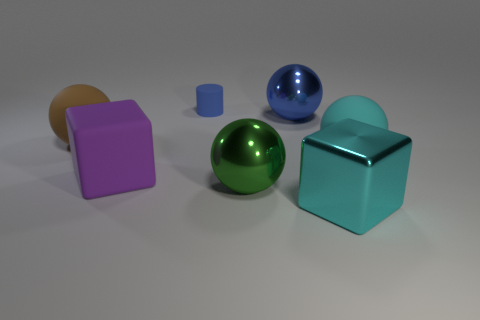What size is the metal sphere that is the same color as the tiny rubber object?
Provide a succinct answer. Large. How many large objects are both right of the large blue metal sphere and behind the large purple object?
Your answer should be very brief. 1. What is the big blue object made of?
Offer a terse response. Metal. Are there any other things that have the same color as the big rubber cube?
Your answer should be very brief. No. Is the large purple object made of the same material as the tiny blue cylinder?
Make the answer very short. Yes. What number of large purple things are behind the matte sphere to the right of the large cyan thing in front of the large purple rubber object?
Make the answer very short. 0. How many red matte objects are there?
Offer a terse response. 0. Is the number of big cyan metallic blocks to the right of the small object less than the number of big objects that are behind the cyan rubber ball?
Offer a very short reply. Yes. Are there fewer green spheres that are behind the blue cylinder than big green things?
Give a very brief answer. Yes. What is the thing that is to the left of the block behind the large ball that is in front of the big rubber cube made of?
Provide a succinct answer. Rubber. 